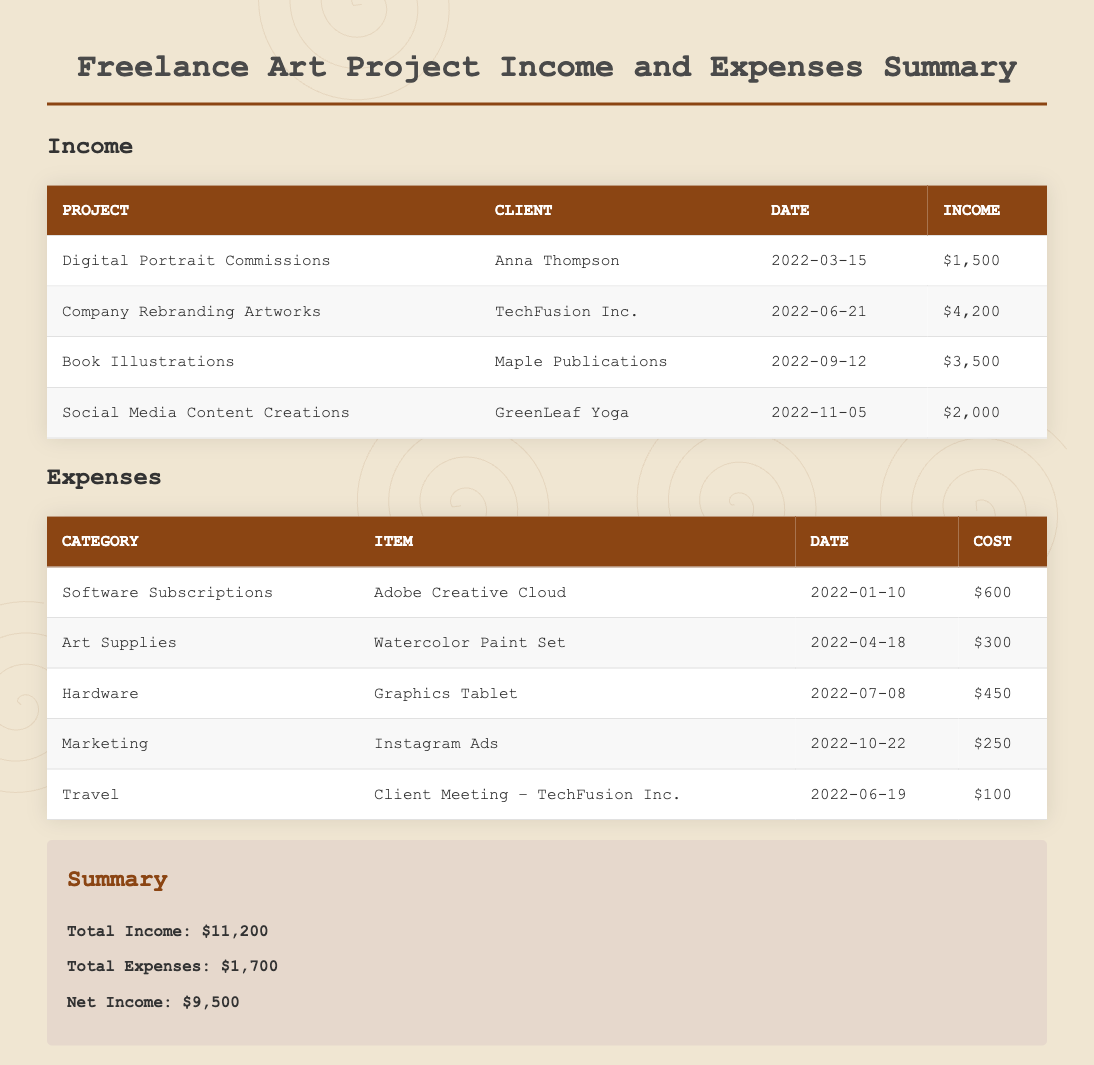What is the total income? The total income is calculated by adding all the income sources listed in the document, which is $1,500 + $4,200 + $3,500 + $2,000 = $11,200.
Answer: $11,200 Who is the client for the Digital Portrait Commissions? The client's name for this project can be found in the income section of the document.
Answer: Anna Thompson How much did you spend on art supplies? The cost of the item related to art supplies is listed within the expenses section of the document.
Answer: $300 What was the date of the Company Rebranding Artworks project? The date can be found associated with the project in the income table.
Answer: 2022-06-21 What is the net income? The net income is found by subtracting total expenses from total income, which is $11,200 - $1,700 = $9,500.
Answer: $9,500 Which project generated the highest income? The project that generated the highest income can be identified by comparing the income amounts listed.
Answer: Company Rebranding Artworks What category does the Graphics Tablet expense fall under? The category of the expense can be identified within the expenses table.
Answer: Hardware How many income sources are listed in the document? The number of income sources can be counted from the income table present in the document.
Answer: 4 What is the total cost for software subscriptions? The total cost for software subscriptions is indicated for a specific item in the expenses section.
Answer: $600 